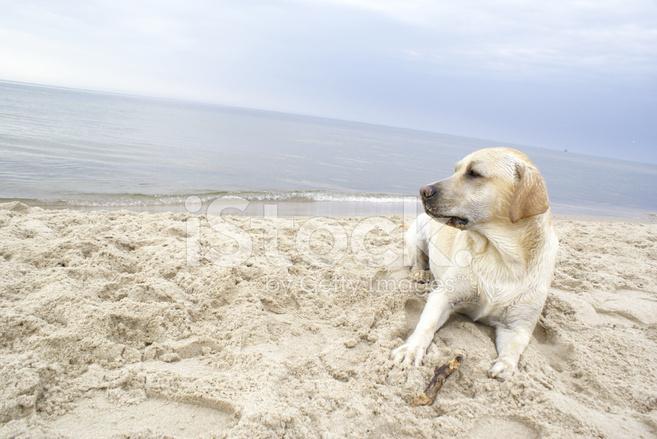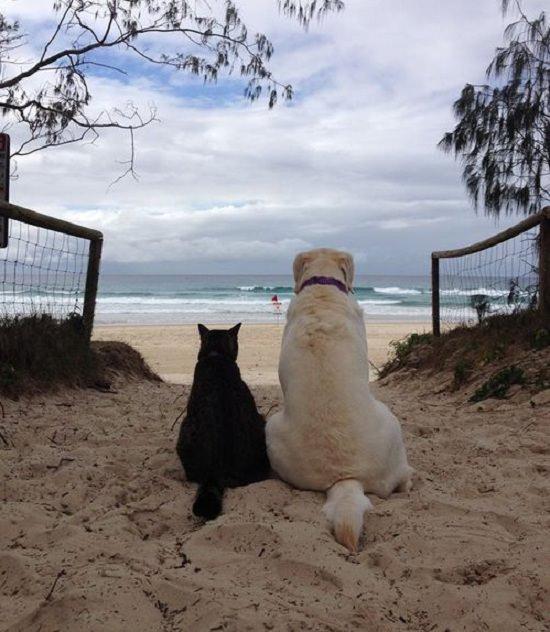The first image is the image on the left, the second image is the image on the right. Analyze the images presented: Is the assertion "One of the images features a dog standing in liquid water." valid? Answer yes or no. No. The first image is the image on the left, the second image is the image on the right. For the images shown, is this caption "There are no more than two animals." true? Answer yes or no. No. 